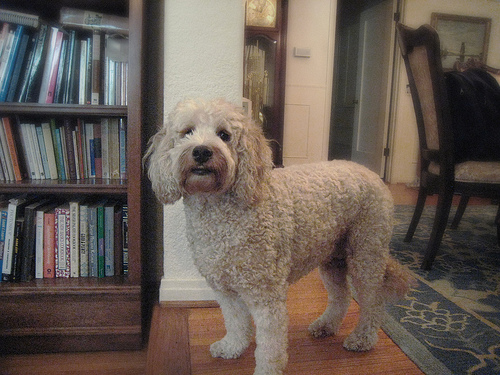<image>
Can you confirm if the dog is in front of the bookshelf? No. The dog is not in front of the bookshelf. The spatial positioning shows a different relationship between these objects. 